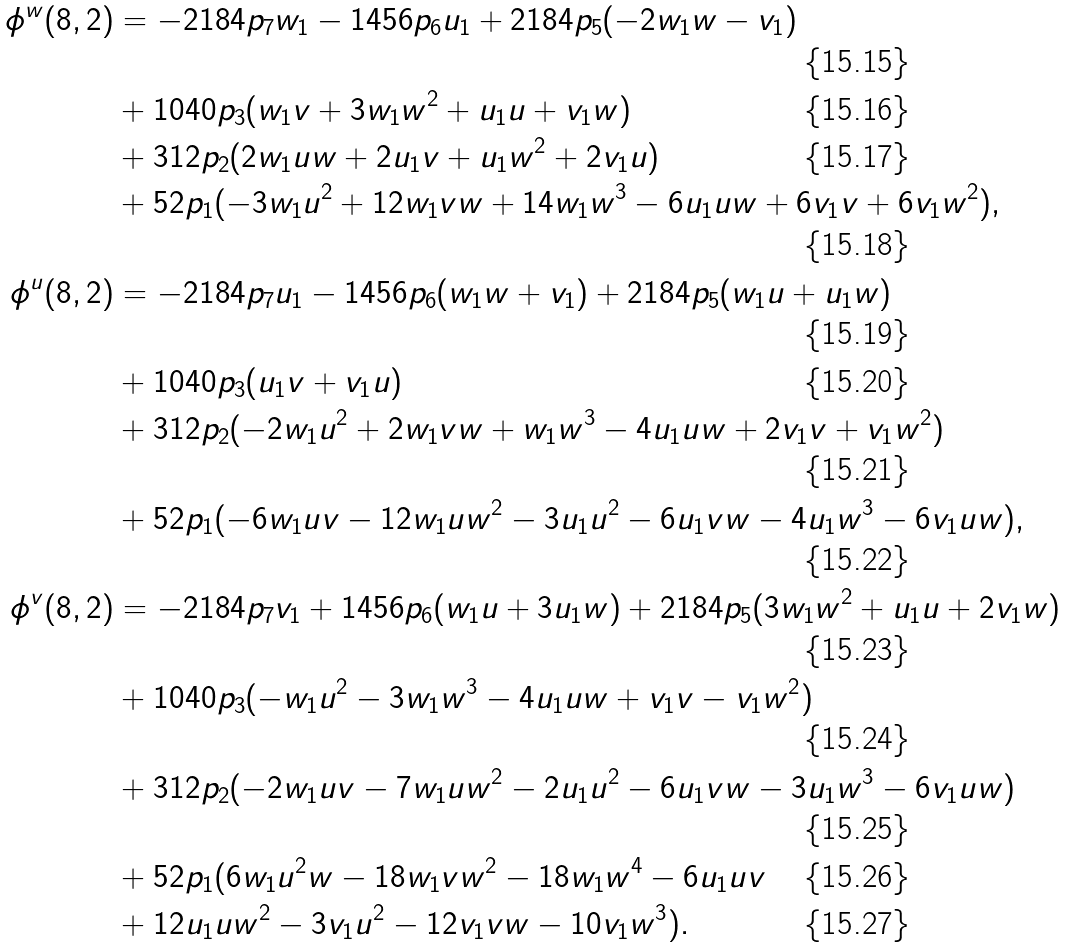Convert formula to latex. <formula><loc_0><loc_0><loc_500><loc_500>\phi ^ { w } ( 8 , 2 ) & = - 2 1 8 4 { p _ { 7 } } w _ { 1 } - 1 4 5 6 { p _ { 6 } } u _ { 1 } + 2 1 8 4 { p _ { 5 } } ( - 2 w _ { 1 } w - v _ { 1 } ) \\ & + 1 0 4 0 { p _ { 3 } } ( w _ { 1 } v + 3 w _ { 1 } w ^ { 2 } + u _ { 1 } u + v _ { 1 } w ) \\ & + 3 1 2 { p _ { 2 } } ( 2 w _ { 1 } u w + 2 u _ { 1 } v + u _ { 1 } w ^ { 2 } + 2 v _ { 1 } u ) \\ & + 5 2 { p _ { 1 } } ( - 3 w _ { 1 } u ^ { 2 } + 1 2 w _ { 1 } v w + 1 4 w _ { 1 } w ^ { 3 } - 6 u _ { 1 } u w + 6 v _ { 1 } v + 6 v _ { 1 } w ^ { 2 } ) , \\ \phi ^ { u } ( 8 , 2 ) & = - 2 1 8 4 { p _ { 7 } } u _ { 1 } - 1 4 5 6 { p _ { 6 } } ( w _ { 1 } w + v _ { 1 } ) + 2 1 8 4 { p _ { 5 } } ( w _ { 1 } u + u _ { 1 } w ) \\ & + 1 0 4 0 { p _ { 3 } } ( u _ { 1 } v + v _ { 1 } u ) \\ & + 3 1 2 { p _ { 2 } } ( - 2 w _ { 1 } u ^ { 2 } + 2 w _ { 1 } v w + w _ { 1 } w ^ { 3 } - 4 u _ { 1 } u w + 2 v _ { 1 } v + v _ { 1 } w ^ { 2 } ) \\ & + 5 2 { p _ { 1 } } ( - 6 w _ { 1 } u v - 1 2 w _ { 1 } u w ^ { 2 } - 3 u _ { 1 } u ^ { 2 } - 6 u _ { 1 } v w - 4 u _ { 1 } w ^ { 3 } - 6 v _ { 1 } u w ) , \\ \phi ^ { v } ( 8 , 2 ) & = - 2 1 8 4 { p _ { 7 } } v _ { 1 } + 1 4 5 6 { p _ { 6 } } ( w _ { 1 } u + 3 u _ { 1 } w ) + 2 1 8 4 { p _ { 5 } } ( 3 w _ { 1 } w ^ { 2 } + u _ { 1 } u + 2 v _ { 1 } w ) \\ & + 1 0 4 0 { p _ { 3 } } ( - w _ { 1 } u ^ { 2 } - 3 w _ { 1 } w ^ { 3 } - 4 u _ { 1 } u w + v _ { 1 } v - v _ { 1 } w ^ { 2 } ) \\ & + 3 1 2 { p _ { 2 } } ( - 2 w _ { 1 } u v - 7 w _ { 1 } u w ^ { 2 } - 2 u _ { 1 } u ^ { 2 } - 6 u _ { 1 } v w - 3 u _ { 1 } w ^ { 3 } - 6 v _ { 1 } u w ) \\ & + 5 2 { p _ { 1 } } ( 6 w _ { 1 } u ^ { 2 } w - 1 8 w _ { 1 } v w ^ { 2 } - 1 8 w _ { 1 } w ^ { 4 } - 6 u _ { 1 } u v \\ & + 1 2 u _ { 1 } u w ^ { 2 } - 3 v _ { 1 } u ^ { 2 } - 1 2 v _ { 1 } v w - 1 0 v _ { 1 } w ^ { 3 } ) .</formula> 